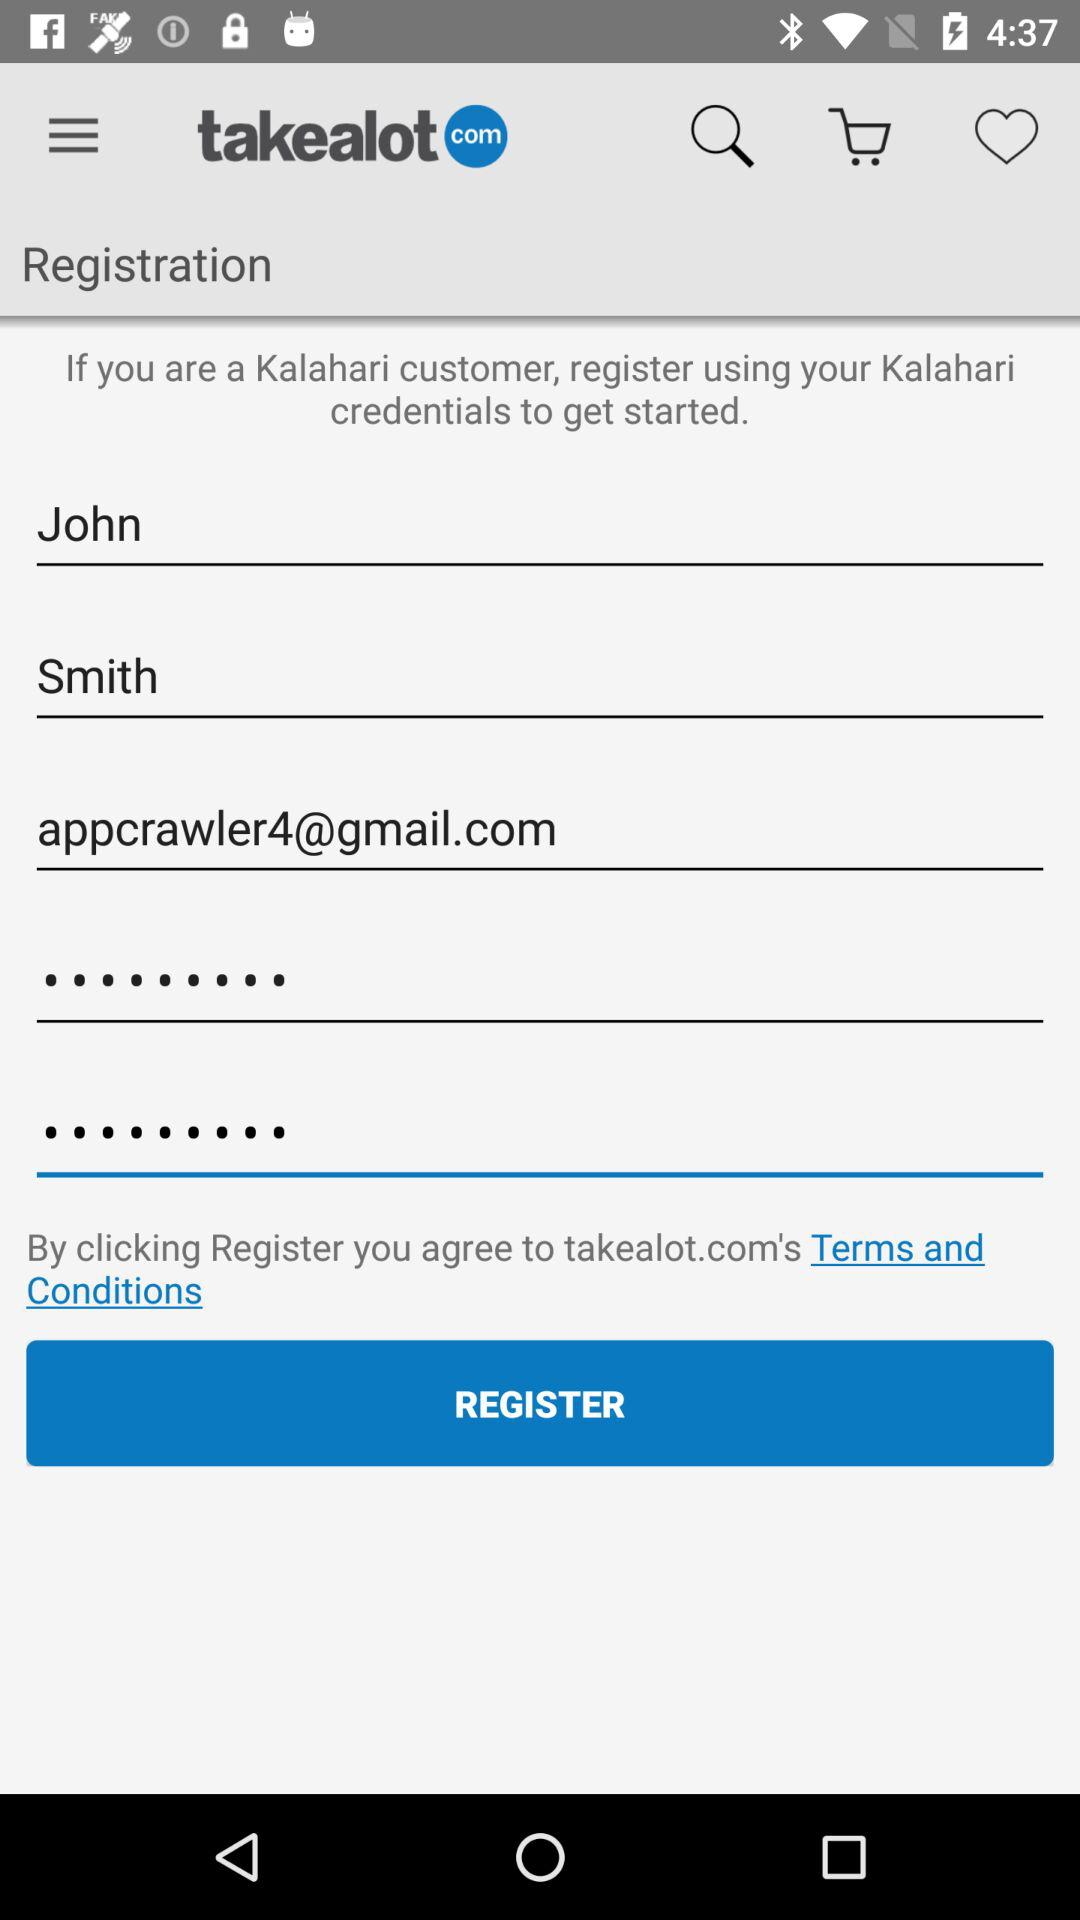What's the user name? The user name is John Smith. 